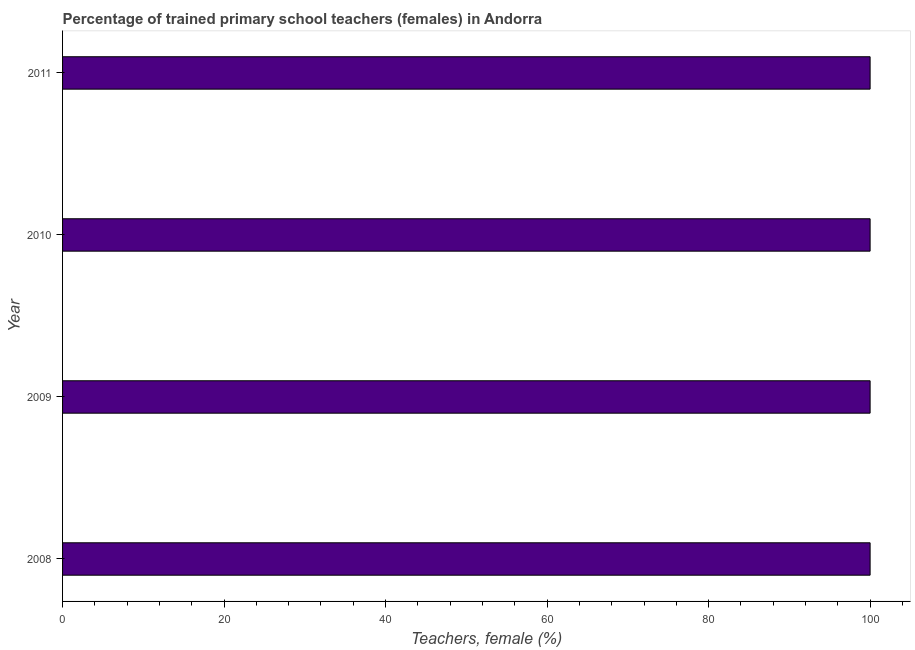What is the title of the graph?
Your response must be concise. Percentage of trained primary school teachers (females) in Andorra. What is the label or title of the X-axis?
Make the answer very short. Teachers, female (%). What is the percentage of trained female teachers in 2010?
Offer a very short reply. 100. In which year was the percentage of trained female teachers maximum?
Give a very brief answer. 2008. What is the sum of the percentage of trained female teachers?
Your answer should be compact. 400. What is the median percentage of trained female teachers?
Provide a short and direct response. 100. In how many years, is the percentage of trained female teachers greater than 36 %?
Your response must be concise. 4. Is the percentage of trained female teachers in 2009 less than that in 2011?
Offer a very short reply. No. Is the difference between the percentage of trained female teachers in 2010 and 2011 greater than the difference between any two years?
Your answer should be very brief. Yes. Is the sum of the percentage of trained female teachers in 2009 and 2011 greater than the maximum percentage of trained female teachers across all years?
Give a very brief answer. Yes. How many bars are there?
Keep it short and to the point. 4. Are all the bars in the graph horizontal?
Offer a terse response. Yes. How many years are there in the graph?
Give a very brief answer. 4. What is the Teachers, female (%) of 2008?
Offer a terse response. 100. What is the Teachers, female (%) in 2010?
Your response must be concise. 100. What is the Teachers, female (%) of 2011?
Make the answer very short. 100. What is the difference between the Teachers, female (%) in 2008 and 2010?
Your answer should be compact. 0. What is the difference between the Teachers, female (%) in 2008 and 2011?
Offer a very short reply. 0. What is the ratio of the Teachers, female (%) in 2008 to that in 2009?
Offer a terse response. 1. What is the ratio of the Teachers, female (%) in 2008 to that in 2010?
Your answer should be compact. 1. What is the ratio of the Teachers, female (%) in 2009 to that in 2010?
Keep it short and to the point. 1. What is the ratio of the Teachers, female (%) in 2009 to that in 2011?
Keep it short and to the point. 1. What is the ratio of the Teachers, female (%) in 2010 to that in 2011?
Make the answer very short. 1. 